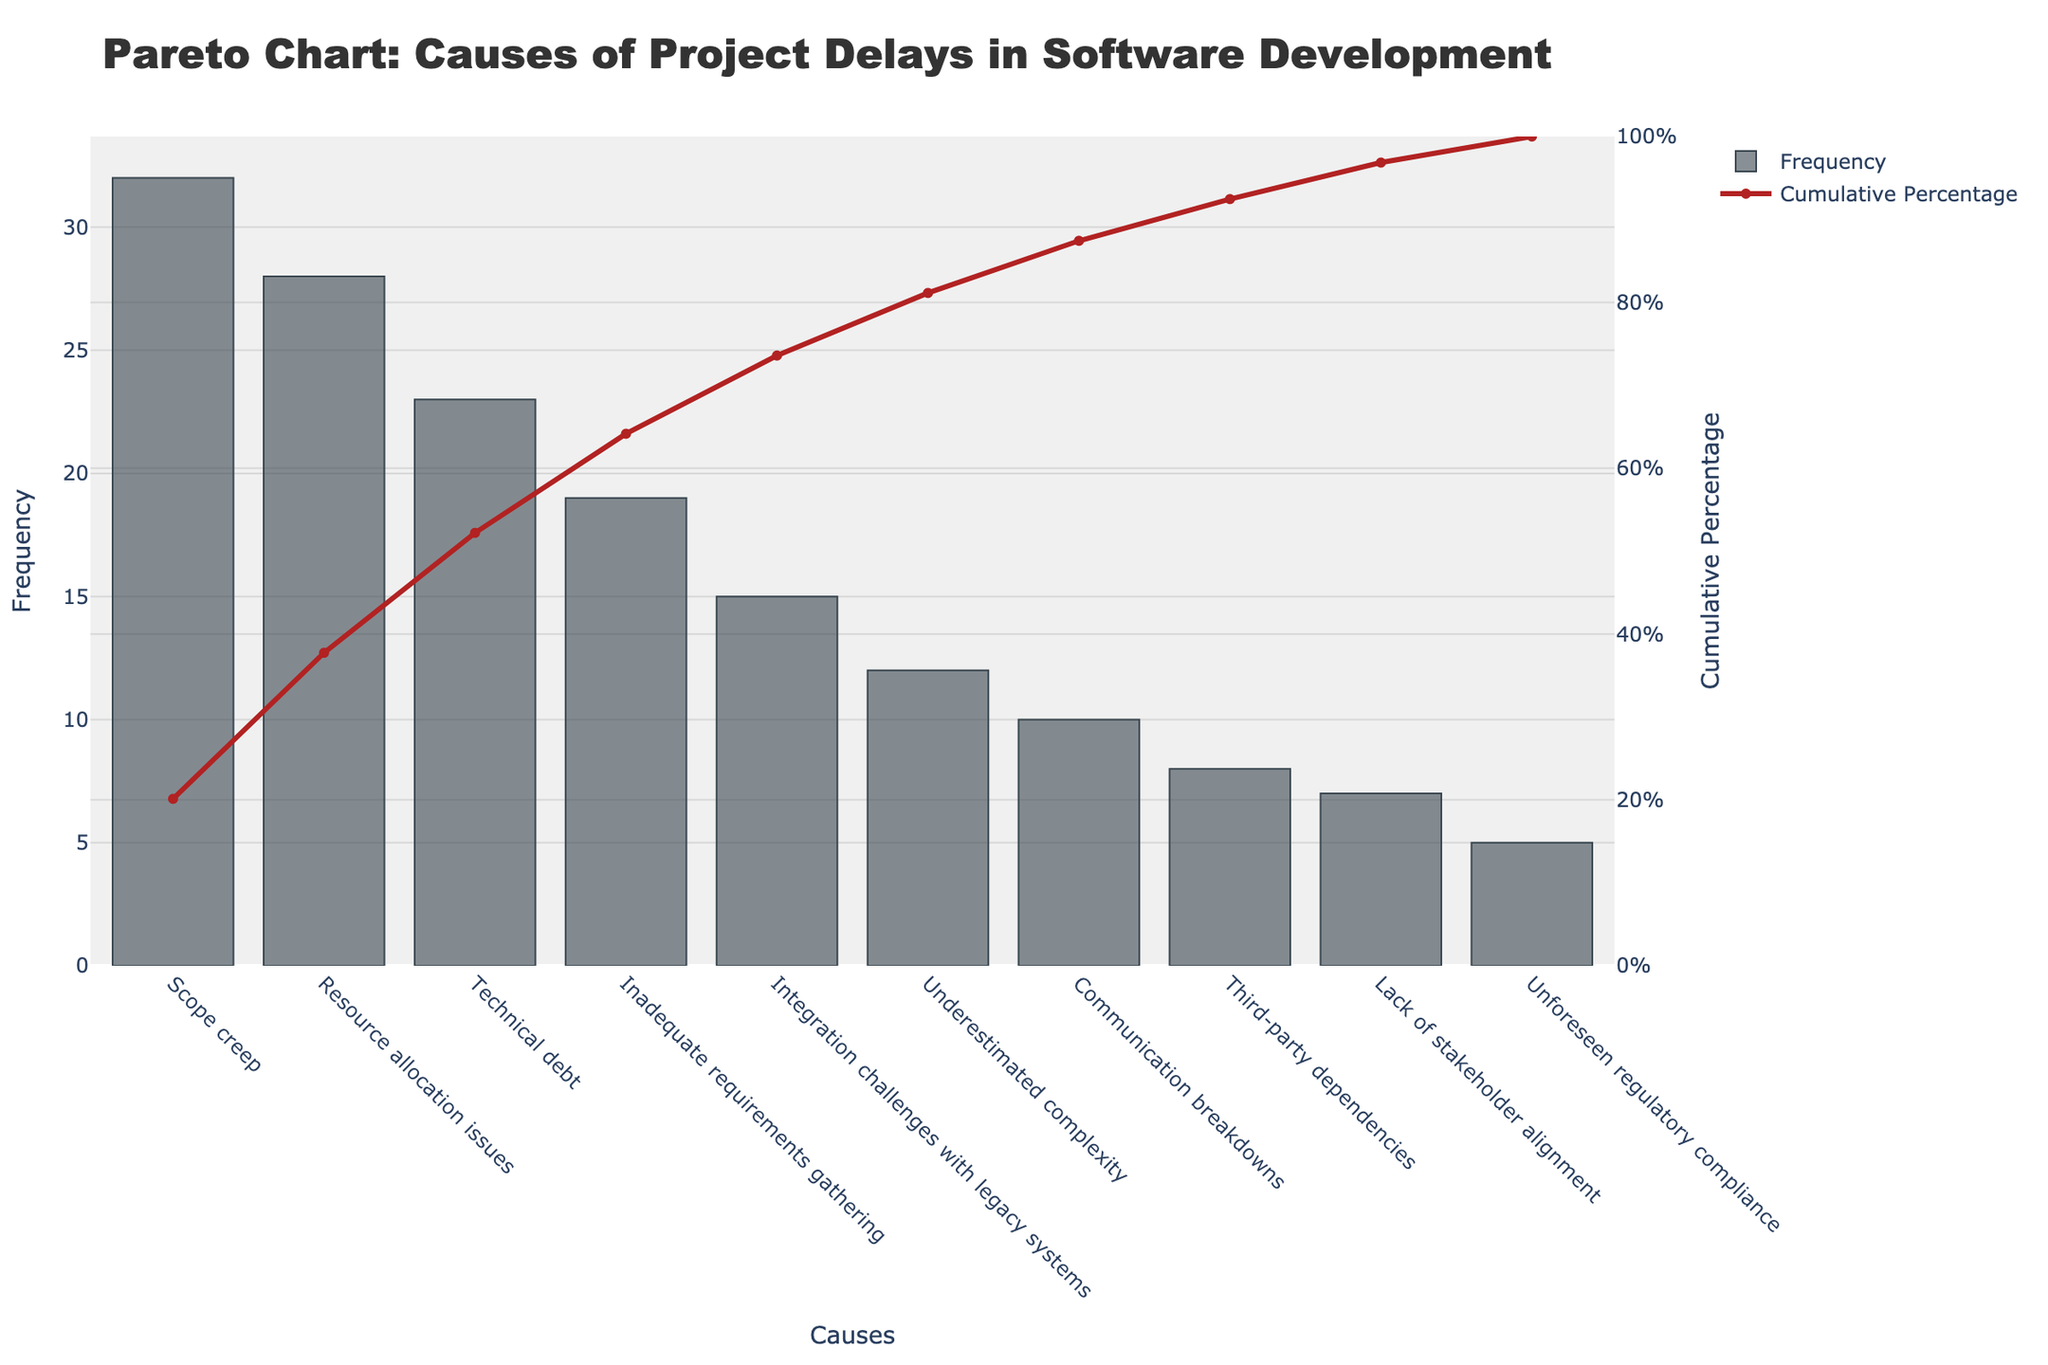What is the title of the chart? The chart title is prominently displayed at the top of the figure. It reads "Pareto Chart: Causes of Project Delays in Software Development".
Answer: Pareto Chart: Causes of Project Delays in Software Development What does the y-axis on the left represent? The y-axis on the left shows the frequency of each cause of project delays. This is indicated by the bar height for each cause.
Answer: Frequency Which cause has the highest frequency of project delays? By examining the highest bar on the graph, we see that "Scope creep" is the first and tallest bar, indicating that it has the highest frequency.
Answer: Scope creep What is the cumulative percentage of project delays explained by the top two causes? To find this, we look at the cumulative percentage line. The top two causes are "Scope creep" and "Resource allocation issues". Add their individual percentages: Scope creep (32) and Resource allocation issues (28), then find the corresponding value on the cumulative percentage curve.
Answer: 50% What percentage of project delays does "Technical debt" represent? The frequency of "Technical debt" is 23. The cumulative percentage at this point, according to the line graph, ranges somewhere between 28% and 60%. Specifically, it's the sum of the percentages of "Scope creep" and "Resource allocation issues" with "Technical debt".
Answer: 60.2% Which cause has the lowest impact on project delays? The shortest bar on the left side of the graph indicates the lowest frequency. The shortest bar represents "Unforeseen regulatory compliance".
Answer: Unforeseen regulatory compliance How many causes account for more than 75% of project delays? To determine this, look at the cumulative percentage line and find the point where it crosses 75%. The causes leading up to this crossing are: "Scope creep", "Resource allocation issues", "Technical debt", "Inadequate requirements gathering", and "Integration challenges with legacy systems" (5 causes).
Answer: 5 Is "Communication breakdowns" a major source of project delays compared to "Scope creep"? Comparing the bars, "Communication breakdowns" has a much shorter bar compared to "Scope creep". This indicates that "Scope creep" has a significantly higher frequency compared to "Communication breakdowns".
Answer: No Do "Underestimated complexity" and "Third-party dependencies" together account for a higher frequency than "Integration challenges with legacy systems"? The frequencies are: "Underestimated complexity" (12), "Third-party dependencies" (8), and "Integration challenges with legacy systems" (15). Adding the first two: 12 + 8 = 20, which is greater than 15.
Answer: Yes Based on the Pareto principle, do the top 20% of causes account for approximately 80% of project delays? The 80/20 rule or Pareto principle suggests that a small number of causes (20%) often account for a large portion of the effect (80%). Here, the first and significant few (Scope creep and Resource allocation issues) cumulatively form about 50% of causes, and by including a few more causes, the cumulative percentage does get nearer to 80%. So, in general, the principle approximately holds true.
Answer: Approximately yes 